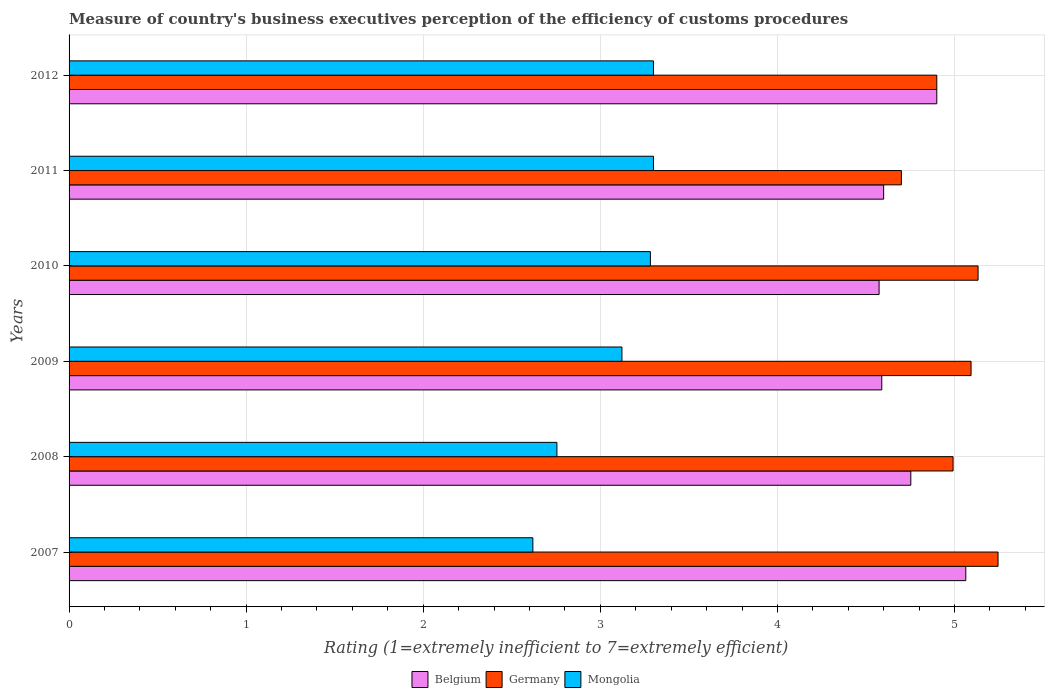How many groups of bars are there?
Give a very brief answer. 6. Are the number of bars on each tick of the Y-axis equal?
Offer a terse response. Yes. How many bars are there on the 1st tick from the bottom?
Your answer should be compact. 3. In how many cases, is the number of bars for a given year not equal to the number of legend labels?
Make the answer very short. 0. What is the rating of the efficiency of customs procedure in Belgium in 2008?
Provide a short and direct response. 4.75. Across all years, what is the maximum rating of the efficiency of customs procedure in Germany?
Offer a terse response. 5.25. Across all years, what is the minimum rating of the efficiency of customs procedure in Mongolia?
Offer a terse response. 2.62. In which year was the rating of the efficiency of customs procedure in Mongolia minimum?
Provide a short and direct response. 2007. What is the total rating of the efficiency of customs procedure in Germany in the graph?
Keep it short and to the point. 30.06. What is the difference between the rating of the efficiency of customs procedure in Belgium in 2008 and that in 2012?
Ensure brevity in your answer.  -0.15. What is the difference between the rating of the efficiency of customs procedure in Belgium in 2009 and the rating of the efficiency of customs procedure in Germany in 2008?
Keep it short and to the point. -0.4. What is the average rating of the efficiency of customs procedure in Belgium per year?
Keep it short and to the point. 4.75. In the year 2011, what is the difference between the rating of the efficiency of customs procedure in Germany and rating of the efficiency of customs procedure in Mongolia?
Ensure brevity in your answer.  1.4. In how many years, is the rating of the efficiency of customs procedure in Germany greater than 3.4 ?
Ensure brevity in your answer.  6. What is the ratio of the rating of the efficiency of customs procedure in Germany in 2008 to that in 2010?
Provide a succinct answer. 0.97. What is the difference between the highest and the second highest rating of the efficiency of customs procedure in Mongolia?
Your answer should be very brief. 0. What is the difference between the highest and the lowest rating of the efficiency of customs procedure in Mongolia?
Your answer should be compact. 0.68. In how many years, is the rating of the efficiency of customs procedure in Germany greater than the average rating of the efficiency of customs procedure in Germany taken over all years?
Your answer should be very brief. 3. Is the sum of the rating of the efficiency of customs procedure in Belgium in 2010 and 2012 greater than the maximum rating of the efficiency of customs procedure in Germany across all years?
Your answer should be compact. Yes. What does the 2nd bar from the bottom in 2009 represents?
Give a very brief answer. Germany. What is the difference between two consecutive major ticks on the X-axis?
Offer a terse response. 1. Are the values on the major ticks of X-axis written in scientific E-notation?
Your answer should be compact. No. Does the graph contain any zero values?
Provide a succinct answer. No. What is the title of the graph?
Provide a succinct answer. Measure of country's business executives perception of the efficiency of customs procedures. What is the label or title of the X-axis?
Provide a short and direct response. Rating (1=extremely inefficient to 7=extremely efficient). What is the Rating (1=extremely inefficient to 7=extremely efficient) in Belgium in 2007?
Provide a succinct answer. 5.06. What is the Rating (1=extremely inefficient to 7=extremely efficient) in Germany in 2007?
Provide a short and direct response. 5.25. What is the Rating (1=extremely inefficient to 7=extremely efficient) in Mongolia in 2007?
Give a very brief answer. 2.62. What is the Rating (1=extremely inefficient to 7=extremely efficient) of Belgium in 2008?
Give a very brief answer. 4.75. What is the Rating (1=extremely inefficient to 7=extremely efficient) of Germany in 2008?
Your response must be concise. 4.99. What is the Rating (1=extremely inefficient to 7=extremely efficient) of Mongolia in 2008?
Offer a very short reply. 2.75. What is the Rating (1=extremely inefficient to 7=extremely efficient) of Belgium in 2009?
Offer a terse response. 4.59. What is the Rating (1=extremely inefficient to 7=extremely efficient) in Germany in 2009?
Give a very brief answer. 5.09. What is the Rating (1=extremely inefficient to 7=extremely efficient) of Mongolia in 2009?
Your answer should be compact. 3.12. What is the Rating (1=extremely inefficient to 7=extremely efficient) in Belgium in 2010?
Give a very brief answer. 4.57. What is the Rating (1=extremely inefficient to 7=extremely efficient) of Germany in 2010?
Ensure brevity in your answer.  5.13. What is the Rating (1=extremely inefficient to 7=extremely efficient) in Mongolia in 2010?
Offer a terse response. 3.28. What is the Rating (1=extremely inefficient to 7=extremely efficient) of Germany in 2012?
Offer a terse response. 4.9. Across all years, what is the maximum Rating (1=extremely inefficient to 7=extremely efficient) in Belgium?
Offer a terse response. 5.06. Across all years, what is the maximum Rating (1=extremely inefficient to 7=extremely efficient) in Germany?
Ensure brevity in your answer.  5.25. Across all years, what is the minimum Rating (1=extremely inefficient to 7=extremely efficient) in Belgium?
Your answer should be compact. 4.57. Across all years, what is the minimum Rating (1=extremely inefficient to 7=extremely efficient) of Germany?
Offer a terse response. 4.7. Across all years, what is the minimum Rating (1=extremely inefficient to 7=extremely efficient) in Mongolia?
Give a very brief answer. 2.62. What is the total Rating (1=extremely inefficient to 7=extremely efficient) in Belgium in the graph?
Keep it short and to the point. 28.48. What is the total Rating (1=extremely inefficient to 7=extremely efficient) in Germany in the graph?
Your response must be concise. 30.06. What is the total Rating (1=extremely inefficient to 7=extremely efficient) in Mongolia in the graph?
Provide a short and direct response. 18.38. What is the difference between the Rating (1=extremely inefficient to 7=extremely efficient) in Belgium in 2007 and that in 2008?
Your response must be concise. 0.31. What is the difference between the Rating (1=extremely inefficient to 7=extremely efficient) of Germany in 2007 and that in 2008?
Offer a terse response. 0.25. What is the difference between the Rating (1=extremely inefficient to 7=extremely efficient) of Mongolia in 2007 and that in 2008?
Make the answer very short. -0.14. What is the difference between the Rating (1=extremely inefficient to 7=extremely efficient) in Belgium in 2007 and that in 2009?
Your answer should be compact. 0.47. What is the difference between the Rating (1=extremely inefficient to 7=extremely efficient) in Germany in 2007 and that in 2009?
Provide a short and direct response. 0.15. What is the difference between the Rating (1=extremely inefficient to 7=extremely efficient) in Mongolia in 2007 and that in 2009?
Your response must be concise. -0.5. What is the difference between the Rating (1=extremely inefficient to 7=extremely efficient) in Belgium in 2007 and that in 2010?
Provide a short and direct response. 0.49. What is the difference between the Rating (1=extremely inefficient to 7=extremely efficient) in Germany in 2007 and that in 2010?
Your answer should be compact. 0.11. What is the difference between the Rating (1=extremely inefficient to 7=extremely efficient) of Mongolia in 2007 and that in 2010?
Offer a terse response. -0.66. What is the difference between the Rating (1=extremely inefficient to 7=extremely efficient) of Belgium in 2007 and that in 2011?
Give a very brief answer. 0.46. What is the difference between the Rating (1=extremely inefficient to 7=extremely efficient) of Germany in 2007 and that in 2011?
Offer a terse response. 0.55. What is the difference between the Rating (1=extremely inefficient to 7=extremely efficient) of Mongolia in 2007 and that in 2011?
Offer a very short reply. -0.68. What is the difference between the Rating (1=extremely inefficient to 7=extremely efficient) in Belgium in 2007 and that in 2012?
Keep it short and to the point. 0.16. What is the difference between the Rating (1=extremely inefficient to 7=extremely efficient) in Germany in 2007 and that in 2012?
Keep it short and to the point. 0.35. What is the difference between the Rating (1=extremely inefficient to 7=extremely efficient) in Mongolia in 2007 and that in 2012?
Your response must be concise. -0.68. What is the difference between the Rating (1=extremely inefficient to 7=extremely efficient) of Belgium in 2008 and that in 2009?
Make the answer very short. 0.16. What is the difference between the Rating (1=extremely inefficient to 7=extremely efficient) in Germany in 2008 and that in 2009?
Your answer should be compact. -0.1. What is the difference between the Rating (1=extremely inefficient to 7=extremely efficient) in Mongolia in 2008 and that in 2009?
Provide a succinct answer. -0.37. What is the difference between the Rating (1=extremely inefficient to 7=extremely efficient) in Belgium in 2008 and that in 2010?
Provide a short and direct response. 0.18. What is the difference between the Rating (1=extremely inefficient to 7=extremely efficient) in Germany in 2008 and that in 2010?
Ensure brevity in your answer.  -0.14. What is the difference between the Rating (1=extremely inefficient to 7=extremely efficient) in Mongolia in 2008 and that in 2010?
Provide a succinct answer. -0.53. What is the difference between the Rating (1=extremely inefficient to 7=extremely efficient) of Belgium in 2008 and that in 2011?
Your response must be concise. 0.15. What is the difference between the Rating (1=extremely inefficient to 7=extremely efficient) of Germany in 2008 and that in 2011?
Ensure brevity in your answer.  0.29. What is the difference between the Rating (1=extremely inefficient to 7=extremely efficient) of Mongolia in 2008 and that in 2011?
Make the answer very short. -0.55. What is the difference between the Rating (1=extremely inefficient to 7=extremely efficient) of Belgium in 2008 and that in 2012?
Offer a very short reply. -0.15. What is the difference between the Rating (1=extremely inefficient to 7=extremely efficient) of Germany in 2008 and that in 2012?
Your answer should be compact. 0.09. What is the difference between the Rating (1=extremely inefficient to 7=extremely efficient) in Mongolia in 2008 and that in 2012?
Make the answer very short. -0.55. What is the difference between the Rating (1=extremely inefficient to 7=extremely efficient) of Belgium in 2009 and that in 2010?
Your response must be concise. 0.02. What is the difference between the Rating (1=extremely inefficient to 7=extremely efficient) of Germany in 2009 and that in 2010?
Give a very brief answer. -0.04. What is the difference between the Rating (1=extremely inefficient to 7=extremely efficient) of Mongolia in 2009 and that in 2010?
Offer a very short reply. -0.16. What is the difference between the Rating (1=extremely inefficient to 7=extremely efficient) of Belgium in 2009 and that in 2011?
Keep it short and to the point. -0.01. What is the difference between the Rating (1=extremely inefficient to 7=extremely efficient) of Germany in 2009 and that in 2011?
Provide a short and direct response. 0.39. What is the difference between the Rating (1=extremely inefficient to 7=extremely efficient) in Mongolia in 2009 and that in 2011?
Your answer should be compact. -0.18. What is the difference between the Rating (1=extremely inefficient to 7=extremely efficient) of Belgium in 2009 and that in 2012?
Keep it short and to the point. -0.31. What is the difference between the Rating (1=extremely inefficient to 7=extremely efficient) in Germany in 2009 and that in 2012?
Provide a succinct answer. 0.19. What is the difference between the Rating (1=extremely inefficient to 7=extremely efficient) of Mongolia in 2009 and that in 2012?
Your answer should be compact. -0.18. What is the difference between the Rating (1=extremely inefficient to 7=extremely efficient) in Belgium in 2010 and that in 2011?
Keep it short and to the point. -0.03. What is the difference between the Rating (1=extremely inefficient to 7=extremely efficient) of Germany in 2010 and that in 2011?
Your response must be concise. 0.43. What is the difference between the Rating (1=extremely inefficient to 7=extremely efficient) of Mongolia in 2010 and that in 2011?
Provide a succinct answer. -0.02. What is the difference between the Rating (1=extremely inefficient to 7=extremely efficient) of Belgium in 2010 and that in 2012?
Your response must be concise. -0.33. What is the difference between the Rating (1=extremely inefficient to 7=extremely efficient) of Germany in 2010 and that in 2012?
Provide a succinct answer. 0.23. What is the difference between the Rating (1=extremely inefficient to 7=extremely efficient) of Mongolia in 2010 and that in 2012?
Give a very brief answer. -0.02. What is the difference between the Rating (1=extremely inefficient to 7=extremely efficient) in Belgium in 2011 and that in 2012?
Provide a short and direct response. -0.3. What is the difference between the Rating (1=extremely inefficient to 7=extremely efficient) in Germany in 2011 and that in 2012?
Make the answer very short. -0.2. What is the difference between the Rating (1=extremely inefficient to 7=extremely efficient) of Belgium in 2007 and the Rating (1=extremely inefficient to 7=extremely efficient) of Germany in 2008?
Provide a short and direct response. 0.07. What is the difference between the Rating (1=extremely inefficient to 7=extremely efficient) in Belgium in 2007 and the Rating (1=extremely inefficient to 7=extremely efficient) in Mongolia in 2008?
Provide a succinct answer. 2.31. What is the difference between the Rating (1=extremely inefficient to 7=extremely efficient) in Germany in 2007 and the Rating (1=extremely inefficient to 7=extremely efficient) in Mongolia in 2008?
Offer a very short reply. 2.49. What is the difference between the Rating (1=extremely inefficient to 7=extremely efficient) in Belgium in 2007 and the Rating (1=extremely inefficient to 7=extremely efficient) in Germany in 2009?
Offer a terse response. -0.03. What is the difference between the Rating (1=extremely inefficient to 7=extremely efficient) in Belgium in 2007 and the Rating (1=extremely inefficient to 7=extremely efficient) in Mongolia in 2009?
Give a very brief answer. 1.94. What is the difference between the Rating (1=extremely inefficient to 7=extremely efficient) of Germany in 2007 and the Rating (1=extremely inefficient to 7=extremely efficient) of Mongolia in 2009?
Your answer should be very brief. 2.12. What is the difference between the Rating (1=extremely inefficient to 7=extremely efficient) of Belgium in 2007 and the Rating (1=extremely inefficient to 7=extremely efficient) of Germany in 2010?
Give a very brief answer. -0.07. What is the difference between the Rating (1=extremely inefficient to 7=extremely efficient) of Belgium in 2007 and the Rating (1=extremely inefficient to 7=extremely efficient) of Mongolia in 2010?
Offer a very short reply. 1.78. What is the difference between the Rating (1=extremely inefficient to 7=extremely efficient) of Germany in 2007 and the Rating (1=extremely inefficient to 7=extremely efficient) of Mongolia in 2010?
Make the answer very short. 1.96. What is the difference between the Rating (1=extremely inefficient to 7=extremely efficient) in Belgium in 2007 and the Rating (1=extremely inefficient to 7=extremely efficient) in Germany in 2011?
Provide a succinct answer. 0.36. What is the difference between the Rating (1=extremely inefficient to 7=extremely efficient) of Belgium in 2007 and the Rating (1=extremely inefficient to 7=extremely efficient) of Mongolia in 2011?
Your answer should be very brief. 1.76. What is the difference between the Rating (1=extremely inefficient to 7=extremely efficient) in Germany in 2007 and the Rating (1=extremely inefficient to 7=extremely efficient) in Mongolia in 2011?
Your response must be concise. 1.95. What is the difference between the Rating (1=extremely inefficient to 7=extremely efficient) in Belgium in 2007 and the Rating (1=extremely inefficient to 7=extremely efficient) in Germany in 2012?
Ensure brevity in your answer.  0.16. What is the difference between the Rating (1=extremely inefficient to 7=extremely efficient) in Belgium in 2007 and the Rating (1=extremely inefficient to 7=extremely efficient) in Mongolia in 2012?
Provide a succinct answer. 1.76. What is the difference between the Rating (1=extremely inefficient to 7=extremely efficient) in Germany in 2007 and the Rating (1=extremely inefficient to 7=extremely efficient) in Mongolia in 2012?
Give a very brief answer. 1.95. What is the difference between the Rating (1=extremely inefficient to 7=extremely efficient) in Belgium in 2008 and the Rating (1=extremely inefficient to 7=extremely efficient) in Germany in 2009?
Offer a very short reply. -0.34. What is the difference between the Rating (1=extremely inefficient to 7=extremely efficient) of Belgium in 2008 and the Rating (1=extremely inefficient to 7=extremely efficient) of Mongolia in 2009?
Your response must be concise. 1.63. What is the difference between the Rating (1=extremely inefficient to 7=extremely efficient) in Germany in 2008 and the Rating (1=extremely inefficient to 7=extremely efficient) in Mongolia in 2009?
Keep it short and to the point. 1.87. What is the difference between the Rating (1=extremely inefficient to 7=extremely efficient) in Belgium in 2008 and the Rating (1=extremely inefficient to 7=extremely efficient) in Germany in 2010?
Offer a very short reply. -0.38. What is the difference between the Rating (1=extremely inefficient to 7=extremely efficient) in Belgium in 2008 and the Rating (1=extremely inefficient to 7=extremely efficient) in Mongolia in 2010?
Provide a short and direct response. 1.47. What is the difference between the Rating (1=extremely inefficient to 7=extremely efficient) of Germany in 2008 and the Rating (1=extremely inefficient to 7=extremely efficient) of Mongolia in 2010?
Provide a succinct answer. 1.71. What is the difference between the Rating (1=extremely inefficient to 7=extremely efficient) in Belgium in 2008 and the Rating (1=extremely inefficient to 7=extremely efficient) in Germany in 2011?
Keep it short and to the point. 0.05. What is the difference between the Rating (1=extremely inefficient to 7=extremely efficient) of Belgium in 2008 and the Rating (1=extremely inefficient to 7=extremely efficient) of Mongolia in 2011?
Your answer should be very brief. 1.45. What is the difference between the Rating (1=extremely inefficient to 7=extremely efficient) in Germany in 2008 and the Rating (1=extremely inefficient to 7=extremely efficient) in Mongolia in 2011?
Provide a succinct answer. 1.69. What is the difference between the Rating (1=extremely inefficient to 7=extremely efficient) of Belgium in 2008 and the Rating (1=extremely inefficient to 7=extremely efficient) of Germany in 2012?
Your answer should be compact. -0.15. What is the difference between the Rating (1=extremely inefficient to 7=extremely efficient) in Belgium in 2008 and the Rating (1=extremely inefficient to 7=extremely efficient) in Mongolia in 2012?
Your response must be concise. 1.45. What is the difference between the Rating (1=extremely inefficient to 7=extremely efficient) in Germany in 2008 and the Rating (1=extremely inefficient to 7=extremely efficient) in Mongolia in 2012?
Offer a terse response. 1.69. What is the difference between the Rating (1=extremely inefficient to 7=extremely efficient) of Belgium in 2009 and the Rating (1=extremely inefficient to 7=extremely efficient) of Germany in 2010?
Your answer should be compact. -0.54. What is the difference between the Rating (1=extremely inefficient to 7=extremely efficient) of Belgium in 2009 and the Rating (1=extremely inefficient to 7=extremely efficient) of Mongolia in 2010?
Your answer should be very brief. 1.31. What is the difference between the Rating (1=extremely inefficient to 7=extremely efficient) of Germany in 2009 and the Rating (1=extremely inefficient to 7=extremely efficient) of Mongolia in 2010?
Give a very brief answer. 1.81. What is the difference between the Rating (1=extremely inefficient to 7=extremely efficient) in Belgium in 2009 and the Rating (1=extremely inefficient to 7=extremely efficient) in Germany in 2011?
Offer a terse response. -0.11. What is the difference between the Rating (1=extremely inefficient to 7=extremely efficient) of Belgium in 2009 and the Rating (1=extremely inefficient to 7=extremely efficient) of Mongolia in 2011?
Offer a very short reply. 1.29. What is the difference between the Rating (1=extremely inefficient to 7=extremely efficient) of Germany in 2009 and the Rating (1=extremely inefficient to 7=extremely efficient) of Mongolia in 2011?
Provide a succinct answer. 1.79. What is the difference between the Rating (1=extremely inefficient to 7=extremely efficient) in Belgium in 2009 and the Rating (1=extremely inefficient to 7=extremely efficient) in Germany in 2012?
Your answer should be very brief. -0.31. What is the difference between the Rating (1=extremely inefficient to 7=extremely efficient) in Belgium in 2009 and the Rating (1=extremely inefficient to 7=extremely efficient) in Mongolia in 2012?
Give a very brief answer. 1.29. What is the difference between the Rating (1=extremely inefficient to 7=extremely efficient) of Germany in 2009 and the Rating (1=extremely inefficient to 7=extremely efficient) of Mongolia in 2012?
Your answer should be very brief. 1.79. What is the difference between the Rating (1=extremely inefficient to 7=extremely efficient) in Belgium in 2010 and the Rating (1=extremely inefficient to 7=extremely efficient) in Germany in 2011?
Your answer should be very brief. -0.13. What is the difference between the Rating (1=extremely inefficient to 7=extremely efficient) in Belgium in 2010 and the Rating (1=extremely inefficient to 7=extremely efficient) in Mongolia in 2011?
Give a very brief answer. 1.27. What is the difference between the Rating (1=extremely inefficient to 7=extremely efficient) of Germany in 2010 and the Rating (1=extremely inefficient to 7=extremely efficient) of Mongolia in 2011?
Your answer should be compact. 1.83. What is the difference between the Rating (1=extremely inefficient to 7=extremely efficient) of Belgium in 2010 and the Rating (1=extremely inefficient to 7=extremely efficient) of Germany in 2012?
Provide a succinct answer. -0.33. What is the difference between the Rating (1=extremely inefficient to 7=extremely efficient) in Belgium in 2010 and the Rating (1=extremely inefficient to 7=extremely efficient) in Mongolia in 2012?
Keep it short and to the point. 1.27. What is the difference between the Rating (1=extremely inefficient to 7=extremely efficient) in Germany in 2010 and the Rating (1=extremely inefficient to 7=extremely efficient) in Mongolia in 2012?
Provide a short and direct response. 1.83. What is the difference between the Rating (1=extremely inefficient to 7=extremely efficient) in Germany in 2011 and the Rating (1=extremely inefficient to 7=extremely efficient) in Mongolia in 2012?
Offer a very short reply. 1.4. What is the average Rating (1=extremely inefficient to 7=extremely efficient) in Belgium per year?
Provide a short and direct response. 4.75. What is the average Rating (1=extremely inefficient to 7=extremely efficient) in Germany per year?
Keep it short and to the point. 5.01. What is the average Rating (1=extremely inefficient to 7=extremely efficient) in Mongolia per year?
Offer a terse response. 3.06. In the year 2007, what is the difference between the Rating (1=extremely inefficient to 7=extremely efficient) of Belgium and Rating (1=extremely inefficient to 7=extremely efficient) of Germany?
Ensure brevity in your answer.  -0.18. In the year 2007, what is the difference between the Rating (1=extremely inefficient to 7=extremely efficient) in Belgium and Rating (1=extremely inefficient to 7=extremely efficient) in Mongolia?
Offer a terse response. 2.44. In the year 2007, what is the difference between the Rating (1=extremely inefficient to 7=extremely efficient) of Germany and Rating (1=extremely inefficient to 7=extremely efficient) of Mongolia?
Offer a very short reply. 2.63. In the year 2008, what is the difference between the Rating (1=extremely inefficient to 7=extremely efficient) in Belgium and Rating (1=extremely inefficient to 7=extremely efficient) in Germany?
Provide a succinct answer. -0.24. In the year 2008, what is the difference between the Rating (1=extremely inefficient to 7=extremely efficient) in Belgium and Rating (1=extremely inefficient to 7=extremely efficient) in Mongolia?
Your answer should be very brief. 2. In the year 2008, what is the difference between the Rating (1=extremely inefficient to 7=extremely efficient) of Germany and Rating (1=extremely inefficient to 7=extremely efficient) of Mongolia?
Give a very brief answer. 2.24. In the year 2009, what is the difference between the Rating (1=extremely inefficient to 7=extremely efficient) of Belgium and Rating (1=extremely inefficient to 7=extremely efficient) of Germany?
Ensure brevity in your answer.  -0.5. In the year 2009, what is the difference between the Rating (1=extremely inefficient to 7=extremely efficient) of Belgium and Rating (1=extremely inefficient to 7=extremely efficient) of Mongolia?
Ensure brevity in your answer.  1.47. In the year 2009, what is the difference between the Rating (1=extremely inefficient to 7=extremely efficient) in Germany and Rating (1=extremely inefficient to 7=extremely efficient) in Mongolia?
Your answer should be very brief. 1.97. In the year 2010, what is the difference between the Rating (1=extremely inefficient to 7=extremely efficient) in Belgium and Rating (1=extremely inefficient to 7=extremely efficient) in Germany?
Provide a short and direct response. -0.56. In the year 2010, what is the difference between the Rating (1=extremely inefficient to 7=extremely efficient) of Belgium and Rating (1=extremely inefficient to 7=extremely efficient) of Mongolia?
Ensure brevity in your answer.  1.29. In the year 2010, what is the difference between the Rating (1=extremely inefficient to 7=extremely efficient) of Germany and Rating (1=extremely inefficient to 7=extremely efficient) of Mongolia?
Your answer should be compact. 1.85. In the year 2011, what is the difference between the Rating (1=extremely inefficient to 7=extremely efficient) in Belgium and Rating (1=extremely inefficient to 7=extremely efficient) in Mongolia?
Provide a short and direct response. 1.3. In the year 2012, what is the difference between the Rating (1=extremely inefficient to 7=extremely efficient) in Belgium and Rating (1=extremely inefficient to 7=extremely efficient) in Germany?
Offer a very short reply. 0. In the year 2012, what is the difference between the Rating (1=extremely inefficient to 7=extremely efficient) of Germany and Rating (1=extremely inefficient to 7=extremely efficient) of Mongolia?
Keep it short and to the point. 1.6. What is the ratio of the Rating (1=extremely inefficient to 7=extremely efficient) of Belgium in 2007 to that in 2008?
Your answer should be very brief. 1.07. What is the ratio of the Rating (1=extremely inefficient to 7=extremely efficient) in Germany in 2007 to that in 2008?
Offer a terse response. 1.05. What is the ratio of the Rating (1=extremely inefficient to 7=extremely efficient) in Mongolia in 2007 to that in 2008?
Give a very brief answer. 0.95. What is the ratio of the Rating (1=extremely inefficient to 7=extremely efficient) of Belgium in 2007 to that in 2009?
Your answer should be very brief. 1.1. What is the ratio of the Rating (1=extremely inefficient to 7=extremely efficient) of Germany in 2007 to that in 2009?
Keep it short and to the point. 1.03. What is the ratio of the Rating (1=extremely inefficient to 7=extremely efficient) of Mongolia in 2007 to that in 2009?
Your answer should be compact. 0.84. What is the ratio of the Rating (1=extremely inefficient to 7=extremely efficient) in Belgium in 2007 to that in 2010?
Ensure brevity in your answer.  1.11. What is the ratio of the Rating (1=extremely inefficient to 7=extremely efficient) of Mongolia in 2007 to that in 2010?
Ensure brevity in your answer.  0.8. What is the ratio of the Rating (1=extremely inefficient to 7=extremely efficient) of Belgium in 2007 to that in 2011?
Offer a very short reply. 1.1. What is the ratio of the Rating (1=extremely inefficient to 7=extremely efficient) of Germany in 2007 to that in 2011?
Make the answer very short. 1.12. What is the ratio of the Rating (1=extremely inefficient to 7=extremely efficient) of Mongolia in 2007 to that in 2011?
Make the answer very short. 0.79. What is the ratio of the Rating (1=extremely inefficient to 7=extremely efficient) of Belgium in 2007 to that in 2012?
Provide a short and direct response. 1.03. What is the ratio of the Rating (1=extremely inefficient to 7=extremely efficient) of Germany in 2007 to that in 2012?
Your answer should be compact. 1.07. What is the ratio of the Rating (1=extremely inefficient to 7=extremely efficient) in Mongolia in 2007 to that in 2012?
Give a very brief answer. 0.79. What is the ratio of the Rating (1=extremely inefficient to 7=extremely efficient) of Belgium in 2008 to that in 2009?
Provide a short and direct response. 1.04. What is the ratio of the Rating (1=extremely inefficient to 7=extremely efficient) of Germany in 2008 to that in 2009?
Make the answer very short. 0.98. What is the ratio of the Rating (1=extremely inefficient to 7=extremely efficient) in Mongolia in 2008 to that in 2009?
Offer a terse response. 0.88. What is the ratio of the Rating (1=extremely inefficient to 7=extremely efficient) of Belgium in 2008 to that in 2010?
Your response must be concise. 1.04. What is the ratio of the Rating (1=extremely inefficient to 7=extremely efficient) in Germany in 2008 to that in 2010?
Offer a very short reply. 0.97. What is the ratio of the Rating (1=extremely inefficient to 7=extremely efficient) in Mongolia in 2008 to that in 2010?
Ensure brevity in your answer.  0.84. What is the ratio of the Rating (1=extremely inefficient to 7=extremely efficient) of Germany in 2008 to that in 2011?
Make the answer very short. 1.06. What is the ratio of the Rating (1=extremely inefficient to 7=extremely efficient) of Mongolia in 2008 to that in 2011?
Keep it short and to the point. 0.83. What is the ratio of the Rating (1=extremely inefficient to 7=extremely efficient) of Belgium in 2008 to that in 2012?
Your answer should be very brief. 0.97. What is the ratio of the Rating (1=extremely inefficient to 7=extremely efficient) in Germany in 2008 to that in 2012?
Make the answer very short. 1.02. What is the ratio of the Rating (1=extremely inefficient to 7=extremely efficient) of Mongolia in 2008 to that in 2012?
Ensure brevity in your answer.  0.83. What is the ratio of the Rating (1=extremely inefficient to 7=extremely efficient) in Belgium in 2009 to that in 2010?
Offer a terse response. 1. What is the ratio of the Rating (1=extremely inefficient to 7=extremely efficient) of Mongolia in 2009 to that in 2010?
Provide a succinct answer. 0.95. What is the ratio of the Rating (1=extremely inefficient to 7=extremely efficient) of Germany in 2009 to that in 2011?
Ensure brevity in your answer.  1.08. What is the ratio of the Rating (1=extremely inefficient to 7=extremely efficient) of Mongolia in 2009 to that in 2011?
Keep it short and to the point. 0.95. What is the ratio of the Rating (1=extremely inefficient to 7=extremely efficient) in Belgium in 2009 to that in 2012?
Your answer should be compact. 0.94. What is the ratio of the Rating (1=extremely inefficient to 7=extremely efficient) of Germany in 2009 to that in 2012?
Your answer should be compact. 1.04. What is the ratio of the Rating (1=extremely inefficient to 7=extremely efficient) in Mongolia in 2009 to that in 2012?
Ensure brevity in your answer.  0.95. What is the ratio of the Rating (1=extremely inefficient to 7=extremely efficient) of Belgium in 2010 to that in 2011?
Your answer should be very brief. 0.99. What is the ratio of the Rating (1=extremely inefficient to 7=extremely efficient) in Germany in 2010 to that in 2011?
Your answer should be very brief. 1.09. What is the ratio of the Rating (1=extremely inefficient to 7=extremely efficient) in Belgium in 2010 to that in 2012?
Provide a short and direct response. 0.93. What is the ratio of the Rating (1=extremely inefficient to 7=extremely efficient) in Germany in 2010 to that in 2012?
Offer a very short reply. 1.05. What is the ratio of the Rating (1=extremely inefficient to 7=extremely efficient) of Mongolia in 2010 to that in 2012?
Provide a succinct answer. 0.99. What is the ratio of the Rating (1=extremely inefficient to 7=extremely efficient) of Belgium in 2011 to that in 2012?
Keep it short and to the point. 0.94. What is the ratio of the Rating (1=extremely inefficient to 7=extremely efficient) in Germany in 2011 to that in 2012?
Your answer should be compact. 0.96. What is the ratio of the Rating (1=extremely inefficient to 7=extremely efficient) in Mongolia in 2011 to that in 2012?
Provide a short and direct response. 1. What is the difference between the highest and the second highest Rating (1=extremely inefficient to 7=extremely efficient) of Belgium?
Offer a very short reply. 0.16. What is the difference between the highest and the second highest Rating (1=extremely inefficient to 7=extremely efficient) in Germany?
Your response must be concise. 0.11. What is the difference between the highest and the second highest Rating (1=extremely inefficient to 7=extremely efficient) of Mongolia?
Your answer should be compact. 0. What is the difference between the highest and the lowest Rating (1=extremely inefficient to 7=extremely efficient) of Belgium?
Give a very brief answer. 0.49. What is the difference between the highest and the lowest Rating (1=extremely inefficient to 7=extremely efficient) in Germany?
Give a very brief answer. 0.55. What is the difference between the highest and the lowest Rating (1=extremely inefficient to 7=extremely efficient) in Mongolia?
Make the answer very short. 0.68. 